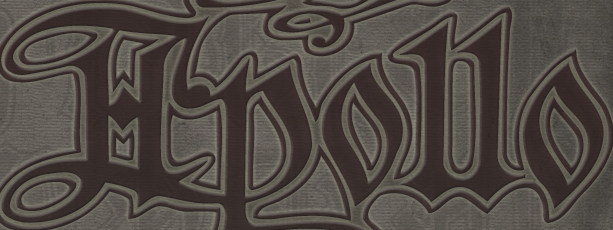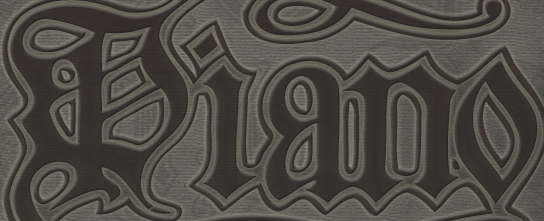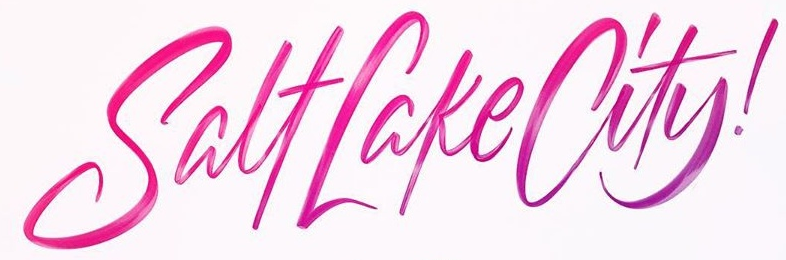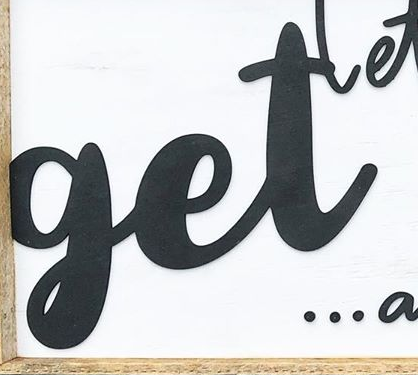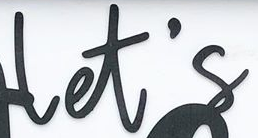Identify the words shown in these images in order, separated by a semicolon. Hpollo; Piano; SalfLakeCity!; get; let's 